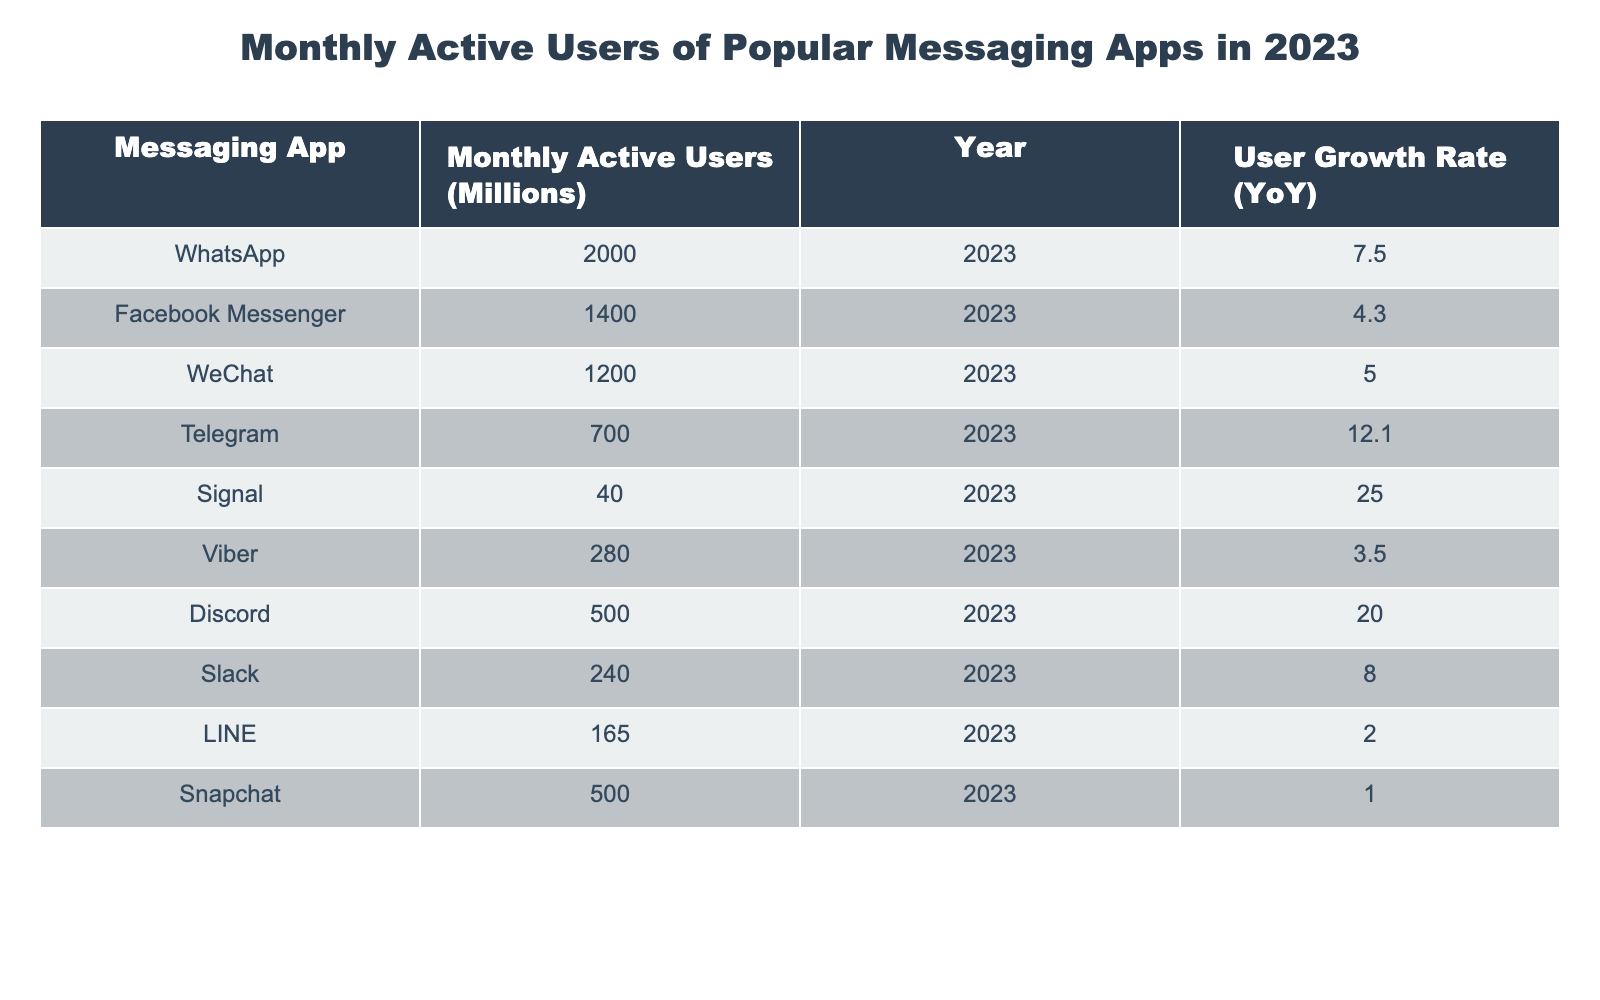What is the Monthly Active Users for WhatsApp in 2023? The table shows that WhatsApp has 2000 Million Monthly Active Users in 2023.
Answer: 2000 Million Which messaging app has the highest Year-on-Year growth rate? By examining the User Growth Rate column, Signal has a growth rate of 25.0 percent, which is the highest among all the apps listed.
Answer: Signal What is the sum of Monthly Active Users for Telegram and Discord? The Monthly Active Users for Telegram is 700 Million and for Discord is 500 Million. Adding these together gives a sum of 700 + 500 = 1200 Million.
Answer: 1200 Million Is the User Growth Rate for Facebook Messenger greater than 5 percent? Checking the User Growth Rate for Facebook Messenger, it is at 4.3 percent, which is less than 5 percent. Therefore, the statement is false.
Answer: No What is the average Monthly Active Users for the top three messaging apps? The top three apps by Monthly Active Users are WhatsApp (2000), Facebook Messenger (1400), and WeChat (1200). The average is calculated as (2000 + 1400 + 1200) / 3 = 1533.33 Million.
Answer: 1533.33 Million Which app has the lowest Monthly Active Users, and what is that number? Reviewing the table, Signal has the lowest Monthly Active Users at 40 Million.
Answer: Signal, 40 Million How many messaging apps have more than 500 Million Monthly Active Users? The table lists six apps with Monthly Active Users greater than 500 Million: WhatsApp, Facebook Messenger, WeChat, Telegram, Discord, and Snapchat. Counting these, we find six apps fit this criterion.
Answer: 6 apps Is the Monthly Active User count for LINE more than that for Viber? Comparing the values, LINE has 165 Million and Viber has 280 Million. Since 165 is less than 280, this statement is false.
Answer: No What is the difference in Monthly Active Users between WhatsApp and Slack? WhatsApp has 2000 Million Monthly Active Users, and Slack has 240 Million. The difference is calculated as 2000 - 240 = 1760 Million.
Answer: 1760 Million 